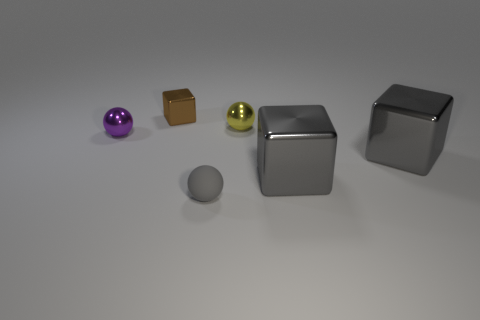Add 3 large cyan rubber cylinders. How many objects exist? 9 Subtract all big gray shiny things. Subtract all gray rubber objects. How many objects are left? 3 Add 3 small gray things. How many small gray things are left? 4 Add 1 gray metallic objects. How many gray metallic objects exist? 3 Subtract 0 red balls. How many objects are left? 6 